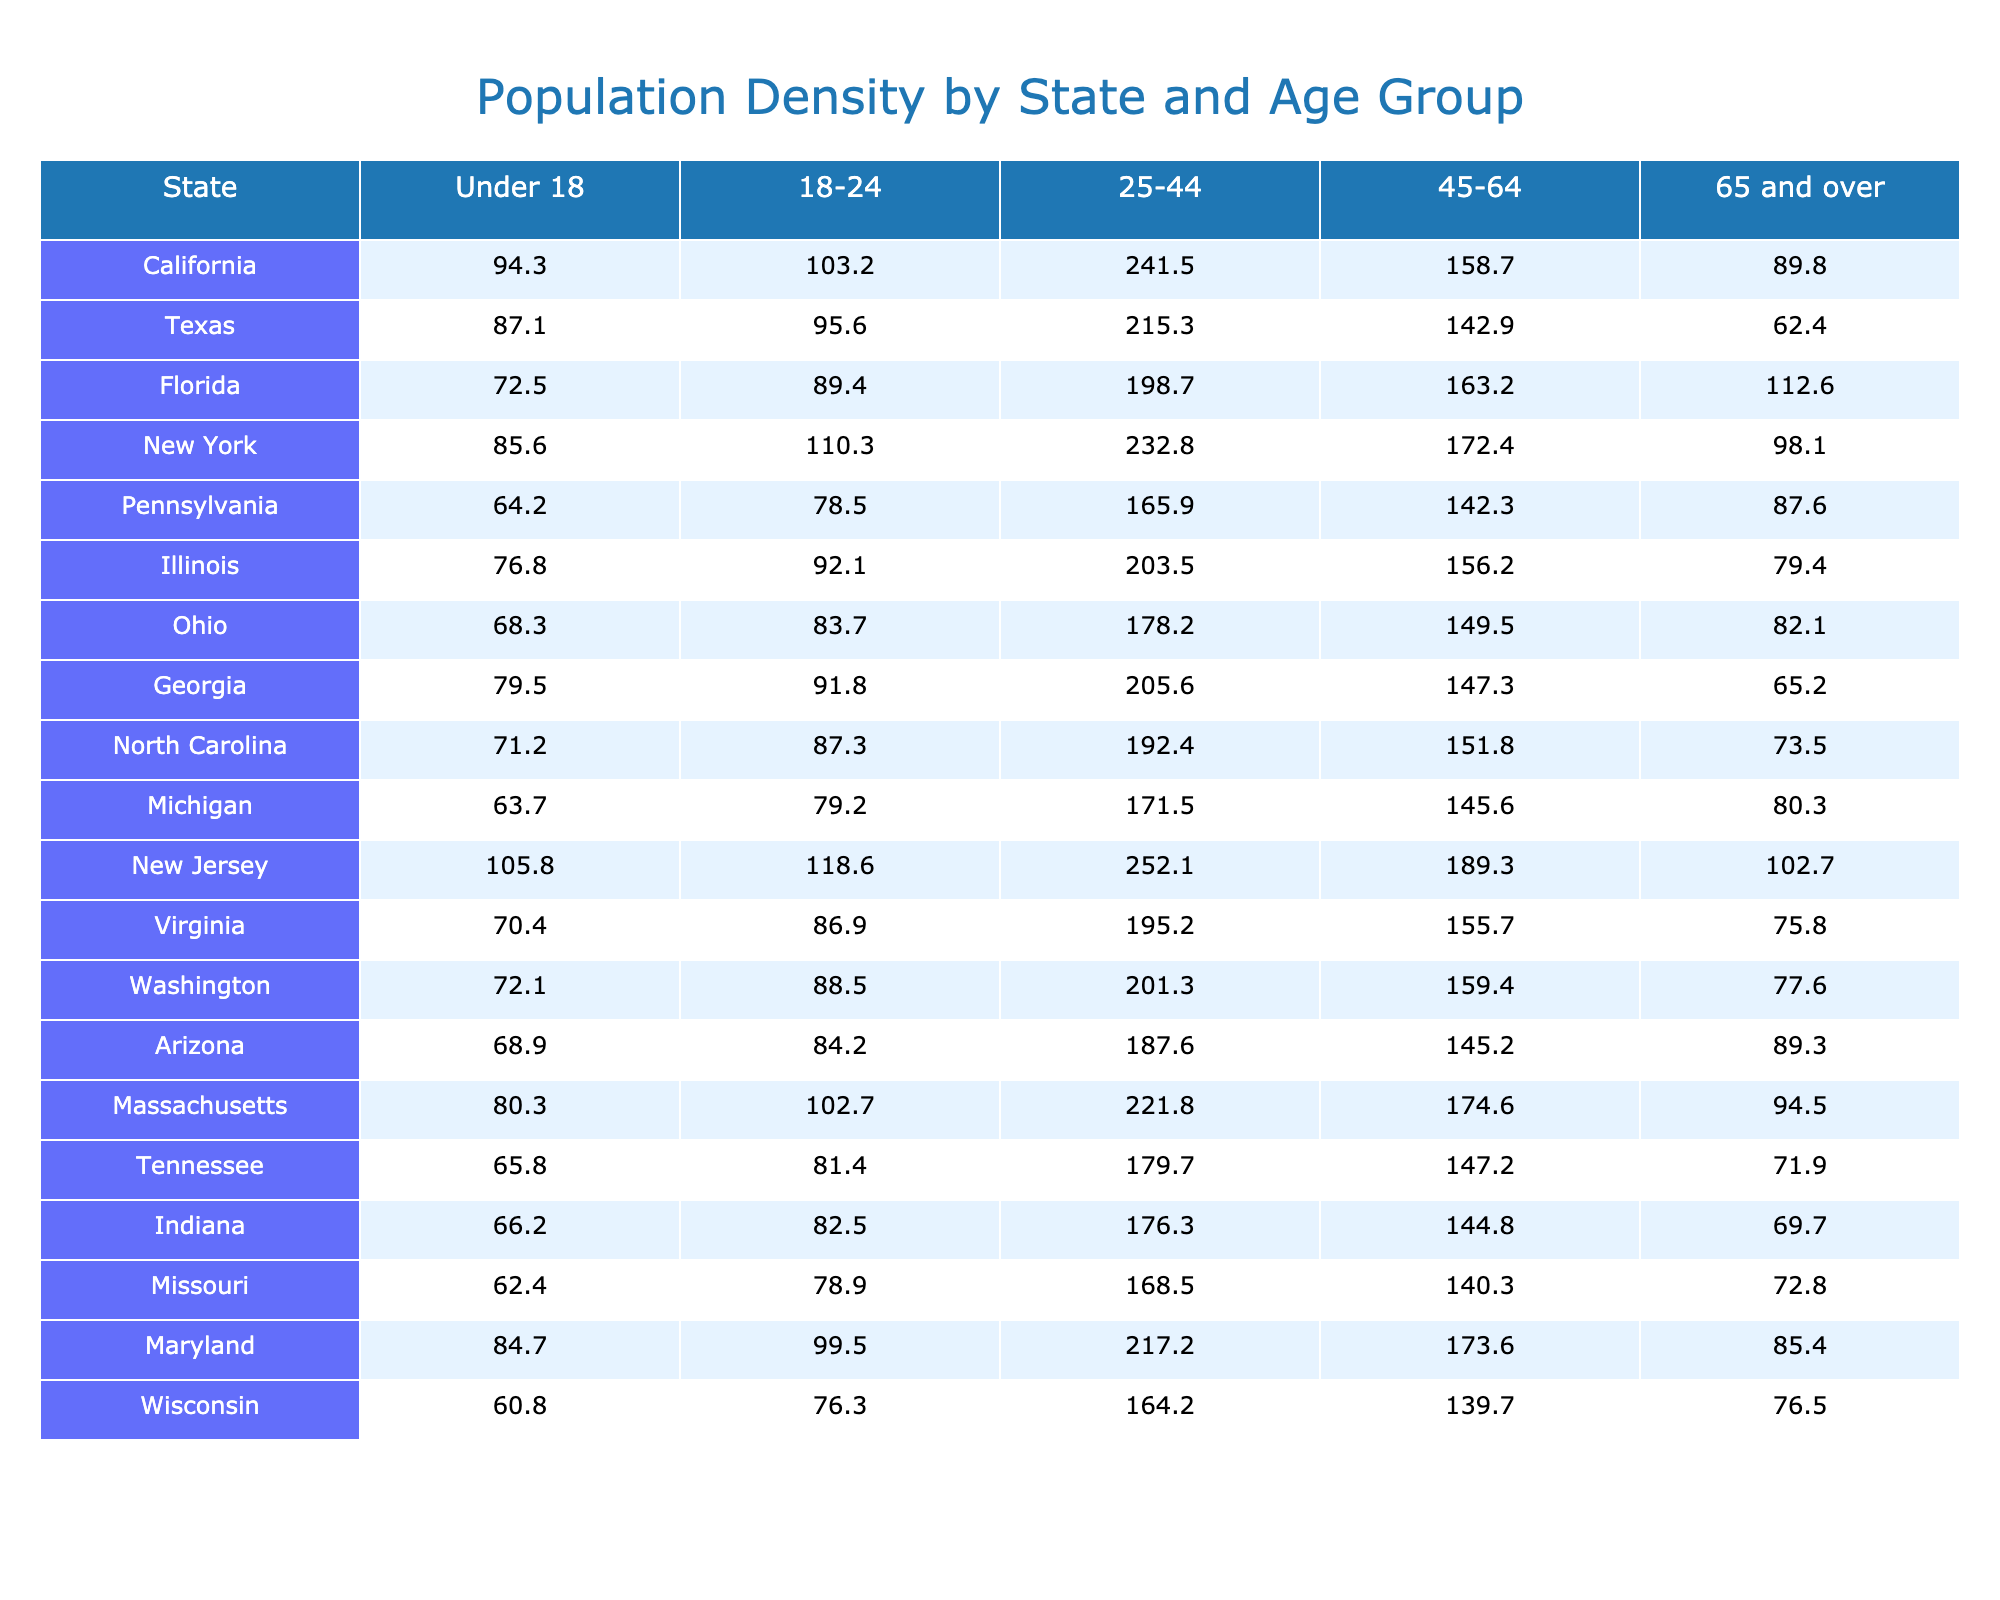What is the population density for the age group 25-44 in California? The value listed for California in the 25-44 age group is 241.5.
Answer: 241.5 Which state has the highest population density for individuals aged 65 and over? By comparing the values for the age group 65 and over across all states, New York has the highest density at 98.1.
Answer: New York What is the average population density for the age group Under 18 across all states? Adding the values for each state's Under 18 group gives a total of 1,309.5 and there are 20 states, so the average is 1,309.5 / 20 = 65.475.
Answer: 65.48 Which state has the lowest population density for the age group 18-24? The lowest value in the 18-24 category is found in Pennsylvania, which has a density of 78.5.
Answer: Pennsylvania In which age group does Arizona have the highest population density? Looking at the values for Arizona, the highest density is in the age group 25-44, with a density of 187.6.
Answer: 25-44 What is the difference in population density for the age group 45-64 between New Jersey and Florida? For New Jersey, the population density in the 45-64 age group is 189.3, and for Florida, it is 163.2. The difference is 189.3 - 163.2 = 26.1.
Answer: 26.1 Is the population density for the age group 18-24 in Texas higher than that in Georgia? Texas has a density of 95.6 in the 18-24 age group, while Georgia has a density of 91.8. Since 95.6 is greater than 91.8, the answer is yes.
Answer: Yes What is the total population density for the age group 65 and over for California, New York, and Florida combined? Adding the values for these states, we get California (89.8) + New York (98.1) + Florida (112.6) = 300.5.
Answer: 300.5 Which state has a population density for the age group 25-44 that is lower than the average density for this group across all states? The average for the 25-44 group across all states is calculated as (the sum of all 25-44 values) / 20, which comes to 202.29. Both Texas (215.3) and Virginia (195.2) have lower values, making them the answer.
Answer: Virginia How do the population densities for the age group 45-64 compare between Illinois and Wisconsin? Illinois has a population density of 156.2 while Wisconsin has 139.7. Since 156.2 is greater than 139.7, Illinois has a higher density in this age group.
Answer: Illinois has a higher density 